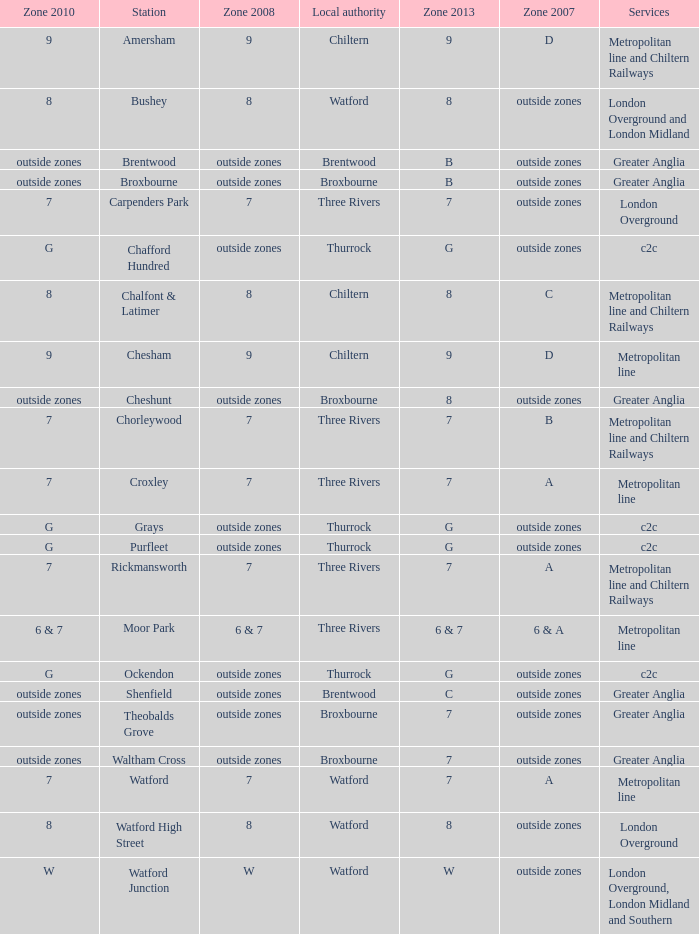Which Local authority has Services of greater anglia? Brentwood, Broxbourne, Broxbourne, Brentwood, Broxbourne, Broxbourne. 